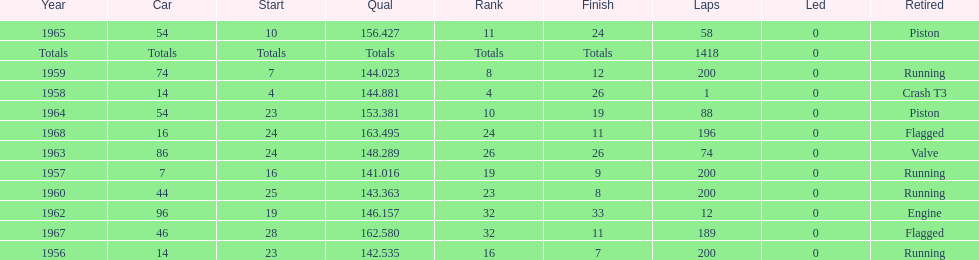Did bob veith drive more indy 500 laps in the 1950s or 1960s? 1960s. 